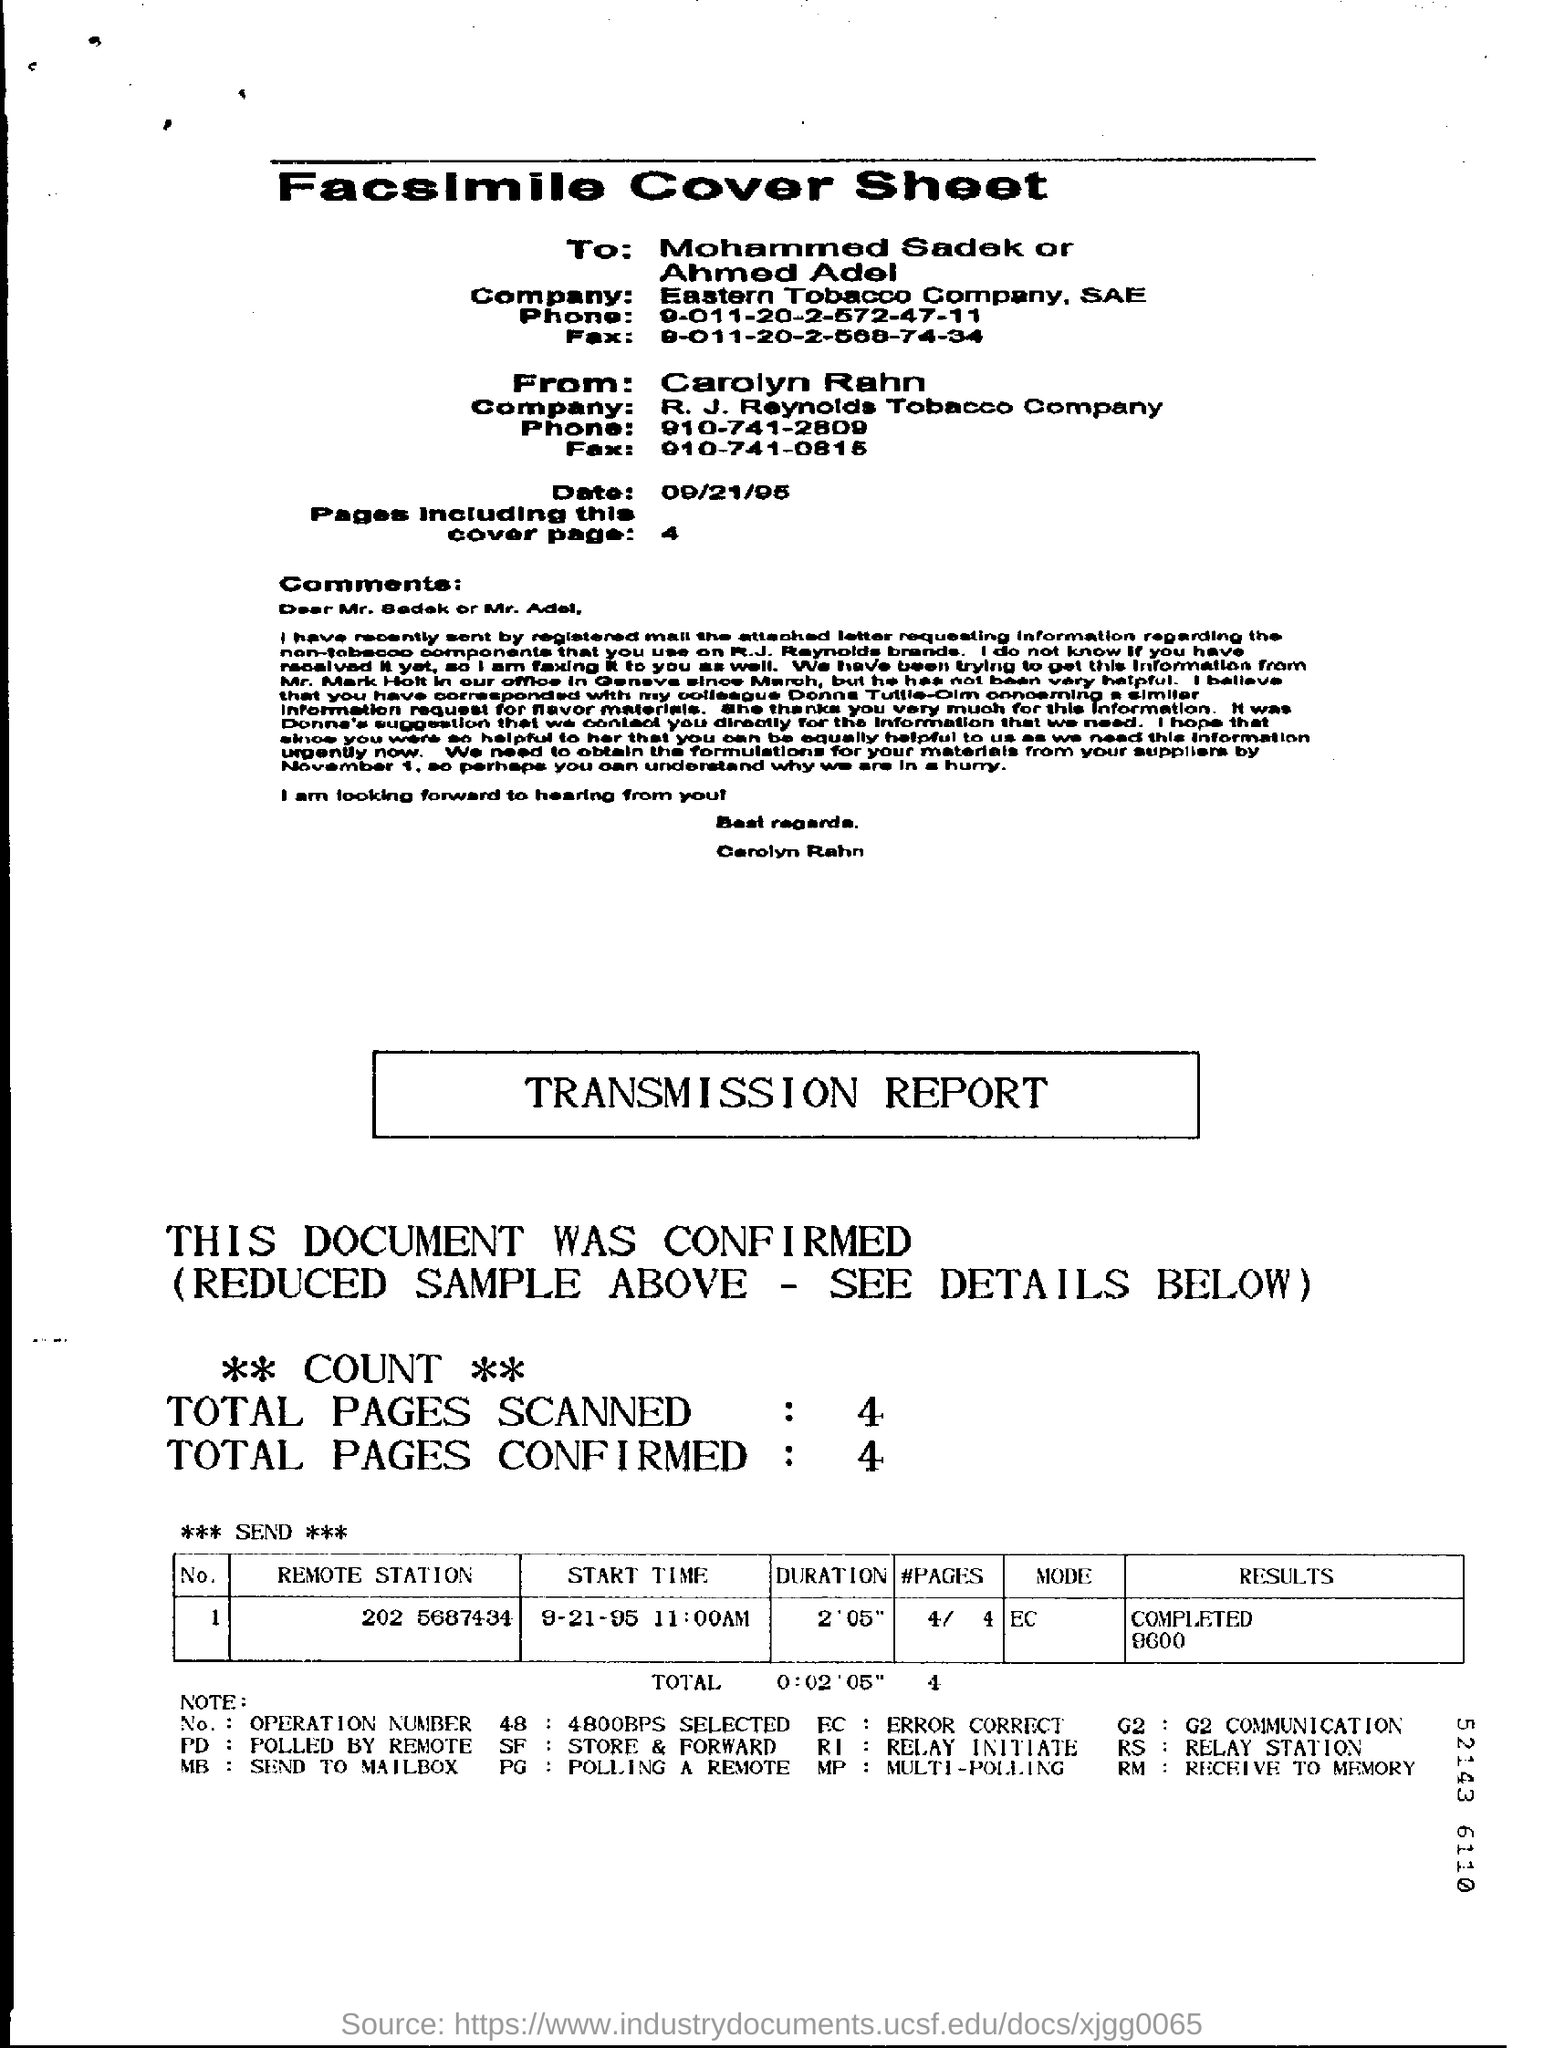When is the Facsimile cover sheet dated?
Give a very brief answer. 09/21/95. How many number of pages are mentioned in the sheet?
Offer a very short reply. 4. How many total number of pages are confirmed?
Offer a very short reply. 4. How many total number of pages are scanned?
Give a very brief answer. 4. 